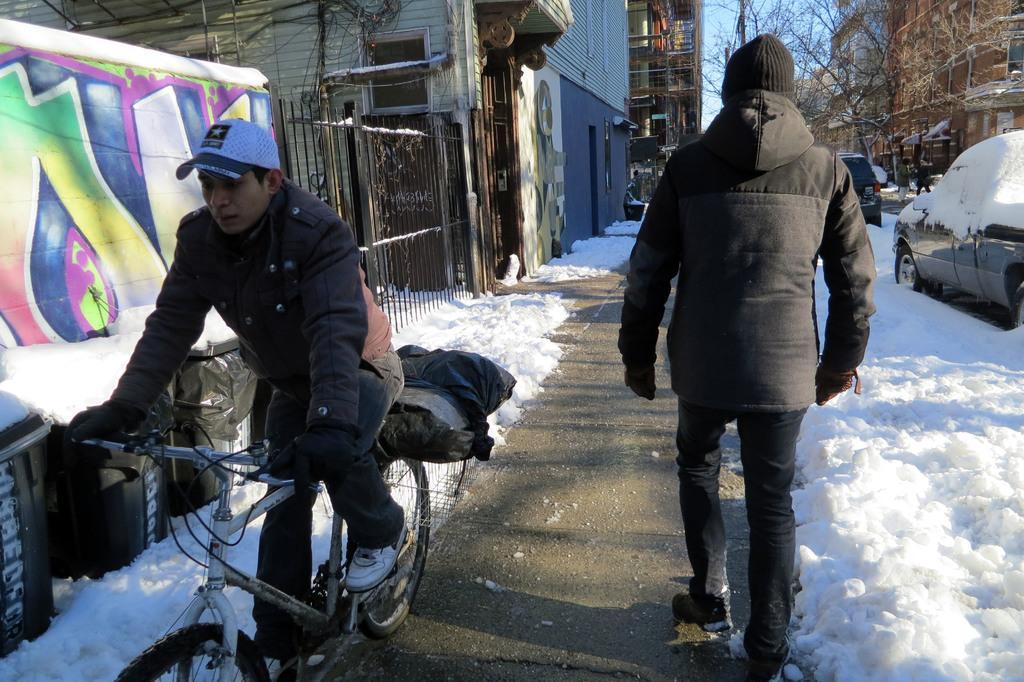In one or two sentences, can you explain what this image depicts? In this image I can see person sitting on the bicycle. In front the person is walking and wearing black dress. Back Side I can see buildings and vehicles on the road. We can see trees and snow. 